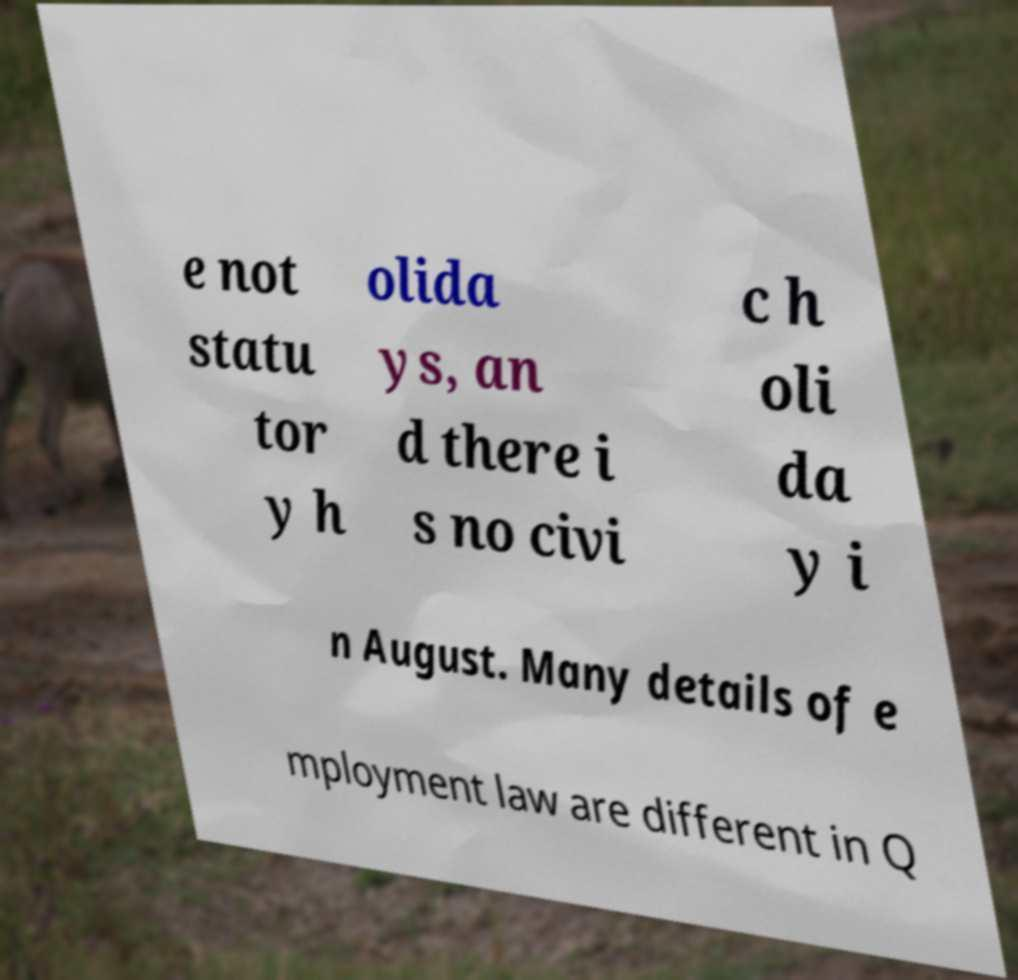Can you read and provide the text displayed in the image?This photo seems to have some interesting text. Can you extract and type it out for me? e not statu tor y h olida ys, an d there i s no civi c h oli da y i n August. Many details of e mployment law are different in Q 